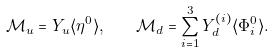Convert formula to latex. <formula><loc_0><loc_0><loc_500><loc_500>\mathcal { M } _ { u } = Y _ { u } \langle \eta ^ { 0 } \rangle , \quad \mathcal { M } _ { d } = \sum _ { i = 1 } ^ { 3 } Y ^ { ( i ) } _ { d } \langle \Phi ^ { 0 } _ { i } \rangle .</formula> 